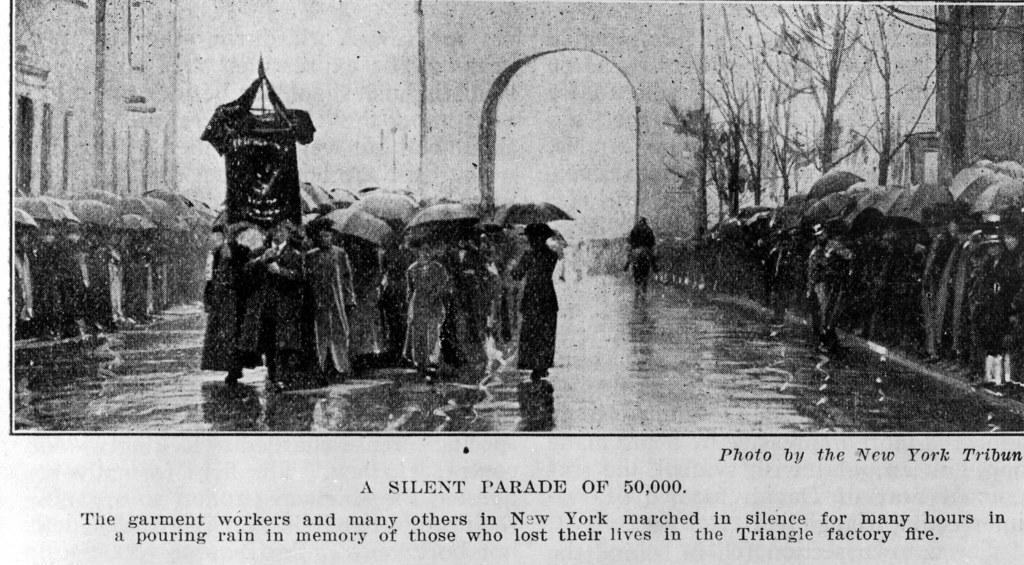What is depicted on the paper in the image? The paper contains a group of people. What are the people in the image doing? The people are standing and holding umbrellas. What can be seen in the background of the image? There are buildings and the sky visible in the image. What is the color scheme of the image? The image is in black and white. Can you tell me how the woman in the image is feeling about her recent loss? There is no woman or mention of a loss in the image; it features a group of people standing and holding umbrellas. What type of rod is being used by the people in the image? There is no rod present in the image; the people are holding umbrellas. 